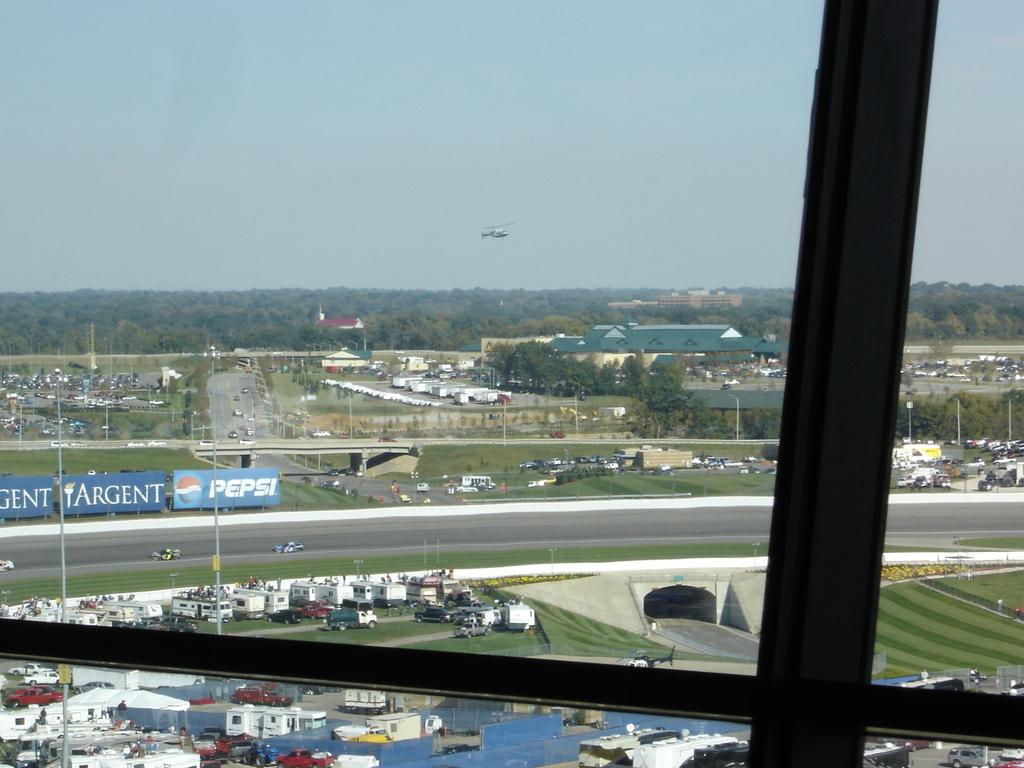Is pepsi a sponsor?
Your answer should be very brief. Yes. What is the cool drink name advertised in the board?
Provide a short and direct response. Pepsi. 